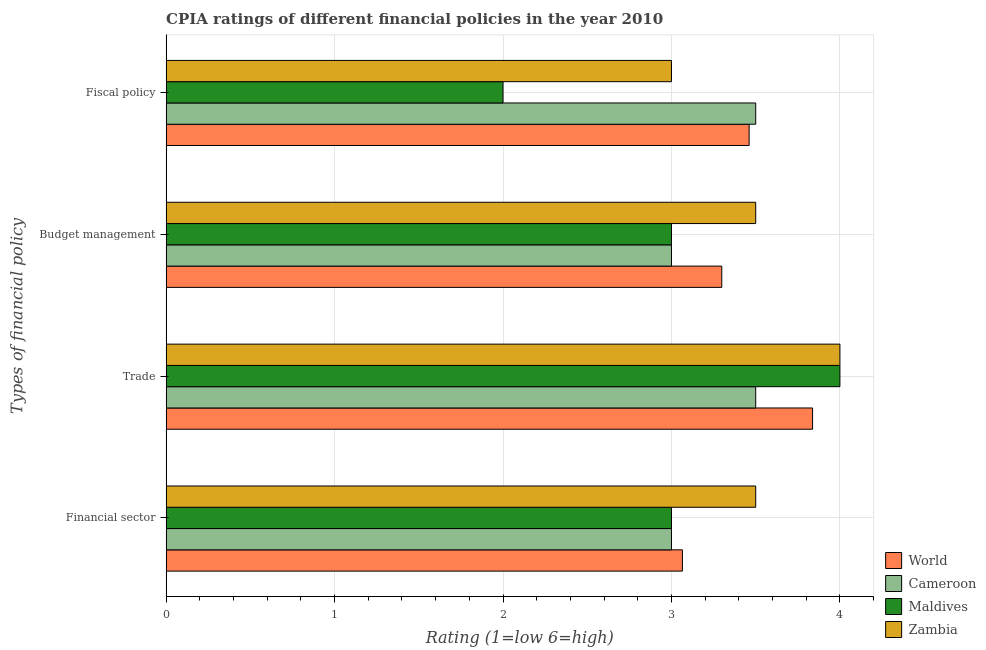How many different coloured bars are there?
Make the answer very short. 4. How many groups of bars are there?
Offer a terse response. 4. What is the label of the 1st group of bars from the top?
Provide a succinct answer. Fiscal policy. Across all countries, what is the maximum cpia rating of fiscal policy?
Provide a short and direct response. 3.5. Across all countries, what is the minimum cpia rating of financial sector?
Ensure brevity in your answer.  3. In which country was the cpia rating of budget management maximum?
Give a very brief answer. Zambia. In which country was the cpia rating of trade minimum?
Offer a very short reply. Cameroon. What is the total cpia rating of budget management in the graph?
Ensure brevity in your answer.  12.8. What is the average cpia rating of trade per country?
Provide a short and direct response. 3.83. What is the difference between the cpia rating of fiscal policy and cpia rating of trade in World?
Your answer should be compact. -0.38. In how many countries, is the cpia rating of budget management greater than 2.4 ?
Ensure brevity in your answer.  4. What is the ratio of the cpia rating of fiscal policy in Maldives to that in World?
Ensure brevity in your answer.  0.58. Is the cpia rating of budget management in Cameroon less than that in World?
Give a very brief answer. Yes. Is the difference between the cpia rating of trade in Cameroon and Zambia greater than the difference between the cpia rating of fiscal policy in Cameroon and Zambia?
Provide a succinct answer. No. What is the difference between the highest and the second highest cpia rating of trade?
Offer a terse response. 0. What is the difference between the highest and the lowest cpia rating of trade?
Provide a succinct answer. 0.5. Is the sum of the cpia rating of trade in Cameroon and World greater than the maximum cpia rating of financial sector across all countries?
Your answer should be very brief. Yes. Is it the case that in every country, the sum of the cpia rating of budget management and cpia rating of financial sector is greater than the sum of cpia rating of trade and cpia rating of fiscal policy?
Provide a succinct answer. No. What does the 1st bar from the top in Trade represents?
Your answer should be very brief. Zambia. What does the 4th bar from the bottom in Budget management represents?
Provide a short and direct response. Zambia. How many countries are there in the graph?
Give a very brief answer. 4. How many legend labels are there?
Offer a very short reply. 4. How are the legend labels stacked?
Your answer should be compact. Vertical. What is the title of the graph?
Give a very brief answer. CPIA ratings of different financial policies in the year 2010. What is the label or title of the Y-axis?
Make the answer very short. Types of financial policy. What is the Rating (1=low 6=high) in World in Financial sector?
Your response must be concise. 3.06. What is the Rating (1=low 6=high) in Cameroon in Financial sector?
Ensure brevity in your answer.  3. What is the Rating (1=low 6=high) in Maldives in Financial sector?
Your response must be concise. 3. What is the Rating (1=low 6=high) of Zambia in Financial sector?
Your answer should be compact. 3.5. What is the Rating (1=low 6=high) of World in Trade?
Make the answer very short. 3.84. What is the Rating (1=low 6=high) of Cameroon in Trade?
Offer a terse response. 3.5. What is the Rating (1=low 6=high) in Zambia in Trade?
Your answer should be very brief. 4. What is the Rating (1=low 6=high) in World in Budget management?
Your answer should be compact. 3.3. What is the Rating (1=low 6=high) in Maldives in Budget management?
Offer a very short reply. 3. What is the Rating (1=low 6=high) in Zambia in Budget management?
Offer a very short reply. 3.5. What is the Rating (1=low 6=high) of World in Fiscal policy?
Ensure brevity in your answer.  3.46. What is the Rating (1=low 6=high) of Zambia in Fiscal policy?
Give a very brief answer. 3. Across all Types of financial policy, what is the maximum Rating (1=low 6=high) of World?
Your response must be concise. 3.84. Across all Types of financial policy, what is the maximum Rating (1=low 6=high) in Cameroon?
Keep it short and to the point. 3.5. Across all Types of financial policy, what is the minimum Rating (1=low 6=high) in World?
Offer a terse response. 3.06. Across all Types of financial policy, what is the minimum Rating (1=low 6=high) of Zambia?
Your answer should be very brief. 3. What is the total Rating (1=low 6=high) in World in the graph?
Make the answer very short. 13.66. What is the total Rating (1=low 6=high) of Maldives in the graph?
Give a very brief answer. 12. What is the difference between the Rating (1=low 6=high) of World in Financial sector and that in Trade?
Your answer should be compact. -0.77. What is the difference between the Rating (1=low 6=high) in Cameroon in Financial sector and that in Trade?
Make the answer very short. -0.5. What is the difference between the Rating (1=low 6=high) of World in Financial sector and that in Budget management?
Provide a short and direct response. -0.23. What is the difference between the Rating (1=low 6=high) in Cameroon in Financial sector and that in Budget management?
Provide a short and direct response. 0. What is the difference between the Rating (1=low 6=high) of World in Financial sector and that in Fiscal policy?
Provide a short and direct response. -0.4. What is the difference between the Rating (1=low 6=high) in Zambia in Financial sector and that in Fiscal policy?
Give a very brief answer. 0.5. What is the difference between the Rating (1=low 6=high) of World in Trade and that in Budget management?
Your answer should be compact. 0.54. What is the difference between the Rating (1=low 6=high) of Cameroon in Trade and that in Budget management?
Your answer should be compact. 0.5. What is the difference between the Rating (1=low 6=high) in Zambia in Trade and that in Budget management?
Your response must be concise. 0.5. What is the difference between the Rating (1=low 6=high) in World in Trade and that in Fiscal policy?
Your answer should be very brief. 0.38. What is the difference between the Rating (1=low 6=high) of Cameroon in Trade and that in Fiscal policy?
Offer a terse response. 0. What is the difference between the Rating (1=low 6=high) in Maldives in Trade and that in Fiscal policy?
Provide a succinct answer. 2. What is the difference between the Rating (1=low 6=high) of World in Budget management and that in Fiscal policy?
Provide a short and direct response. -0.16. What is the difference between the Rating (1=low 6=high) of Cameroon in Budget management and that in Fiscal policy?
Offer a very short reply. -0.5. What is the difference between the Rating (1=low 6=high) of Maldives in Budget management and that in Fiscal policy?
Provide a succinct answer. 1. What is the difference between the Rating (1=low 6=high) of Zambia in Budget management and that in Fiscal policy?
Give a very brief answer. 0.5. What is the difference between the Rating (1=low 6=high) of World in Financial sector and the Rating (1=low 6=high) of Cameroon in Trade?
Provide a short and direct response. -0.44. What is the difference between the Rating (1=low 6=high) of World in Financial sector and the Rating (1=low 6=high) of Maldives in Trade?
Your answer should be very brief. -0.94. What is the difference between the Rating (1=low 6=high) of World in Financial sector and the Rating (1=low 6=high) of Zambia in Trade?
Offer a very short reply. -0.94. What is the difference between the Rating (1=low 6=high) of Cameroon in Financial sector and the Rating (1=low 6=high) of Zambia in Trade?
Keep it short and to the point. -1. What is the difference between the Rating (1=low 6=high) in Maldives in Financial sector and the Rating (1=low 6=high) in Zambia in Trade?
Give a very brief answer. -1. What is the difference between the Rating (1=low 6=high) in World in Financial sector and the Rating (1=low 6=high) in Cameroon in Budget management?
Your response must be concise. 0.06. What is the difference between the Rating (1=low 6=high) of World in Financial sector and the Rating (1=low 6=high) of Maldives in Budget management?
Offer a very short reply. 0.06. What is the difference between the Rating (1=low 6=high) of World in Financial sector and the Rating (1=low 6=high) of Zambia in Budget management?
Provide a succinct answer. -0.44. What is the difference between the Rating (1=low 6=high) of Cameroon in Financial sector and the Rating (1=low 6=high) of Maldives in Budget management?
Provide a short and direct response. 0. What is the difference between the Rating (1=low 6=high) of Cameroon in Financial sector and the Rating (1=low 6=high) of Zambia in Budget management?
Your answer should be very brief. -0.5. What is the difference between the Rating (1=low 6=high) of World in Financial sector and the Rating (1=low 6=high) of Cameroon in Fiscal policy?
Give a very brief answer. -0.44. What is the difference between the Rating (1=low 6=high) in World in Financial sector and the Rating (1=low 6=high) in Maldives in Fiscal policy?
Ensure brevity in your answer.  1.06. What is the difference between the Rating (1=low 6=high) in World in Financial sector and the Rating (1=low 6=high) in Zambia in Fiscal policy?
Give a very brief answer. 0.06. What is the difference between the Rating (1=low 6=high) in Cameroon in Financial sector and the Rating (1=low 6=high) in Maldives in Fiscal policy?
Your answer should be compact. 1. What is the difference between the Rating (1=low 6=high) of Cameroon in Financial sector and the Rating (1=low 6=high) of Zambia in Fiscal policy?
Keep it short and to the point. 0. What is the difference between the Rating (1=low 6=high) of World in Trade and the Rating (1=low 6=high) of Cameroon in Budget management?
Give a very brief answer. 0.84. What is the difference between the Rating (1=low 6=high) in World in Trade and the Rating (1=low 6=high) in Maldives in Budget management?
Your response must be concise. 0.84. What is the difference between the Rating (1=low 6=high) in World in Trade and the Rating (1=low 6=high) in Zambia in Budget management?
Offer a very short reply. 0.34. What is the difference between the Rating (1=low 6=high) in Cameroon in Trade and the Rating (1=low 6=high) in Maldives in Budget management?
Your response must be concise. 0.5. What is the difference between the Rating (1=low 6=high) in Maldives in Trade and the Rating (1=low 6=high) in Zambia in Budget management?
Give a very brief answer. 0.5. What is the difference between the Rating (1=low 6=high) of World in Trade and the Rating (1=low 6=high) of Cameroon in Fiscal policy?
Offer a very short reply. 0.34. What is the difference between the Rating (1=low 6=high) in World in Trade and the Rating (1=low 6=high) in Maldives in Fiscal policy?
Offer a very short reply. 1.84. What is the difference between the Rating (1=low 6=high) of World in Trade and the Rating (1=low 6=high) of Zambia in Fiscal policy?
Provide a succinct answer. 0.84. What is the difference between the Rating (1=low 6=high) in Cameroon in Trade and the Rating (1=low 6=high) in Maldives in Fiscal policy?
Ensure brevity in your answer.  1.5. What is the difference between the Rating (1=low 6=high) in Cameroon in Trade and the Rating (1=low 6=high) in Zambia in Fiscal policy?
Keep it short and to the point. 0.5. What is the difference between the Rating (1=low 6=high) of World in Budget management and the Rating (1=low 6=high) of Cameroon in Fiscal policy?
Make the answer very short. -0.2. What is the difference between the Rating (1=low 6=high) of World in Budget management and the Rating (1=low 6=high) of Maldives in Fiscal policy?
Keep it short and to the point. 1.3. What is the difference between the Rating (1=low 6=high) of World in Budget management and the Rating (1=low 6=high) of Zambia in Fiscal policy?
Ensure brevity in your answer.  0.3. What is the difference between the Rating (1=low 6=high) of Cameroon in Budget management and the Rating (1=low 6=high) of Maldives in Fiscal policy?
Offer a terse response. 1. What is the difference between the Rating (1=low 6=high) of Cameroon in Budget management and the Rating (1=low 6=high) of Zambia in Fiscal policy?
Ensure brevity in your answer.  0. What is the difference between the Rating (1=low 6=high) of Maldives in Budget management and the Rating (1=low 6=high) of Zambia in Fiscal policy?
Your answer should be compact. 0. What is the average Rating (1=low 6=high) of World per Types of financial policy?
Offer a terse response. 3.42. What is the average Rating (1=low 6=high) in Maldives per Types of financial policy?
Offer a very short reply. 3. What is the difference between the Rating (1=low 6=high) of World and Rating (1=low 6=high) of Cameroon in Financial sector?
Your answer should be compact. 0.06. What is the difference between the Rating (1=low 6=high) in World and Rating (1=low 6=high) in Maldives in Financial sector?
Offer a terse response. 0.06. What is the difference between the Rating (1=low 6=high) of World and Rating (1=low 6=high) of Zambia in Financial sector?
Provide a succinct answer. -0.44. What is the difference between the Rating (1=low 6=high) of Cameroon and Rating (1=low 6=high) of Maldives in Financial sector?
Your answer should be very brief. 0. What is the difference between the Rating (1=low 6=high) in Cameroon and Rating (1=low 6=high) in Zambia in Financial sector?
Your answer should be very brief. -0.5. What is the difference between the Rating (1=low 6=high) in World and Rating (1=low 6=high) in Cameroon in Trade?
Offer a terse response. 0.34. What is the difference between the Rating (1=low 6=high) in World and Rating (1=low 6=high) in Maldives in Trade?
Make the answer very short. -0.16. What is the difference between the Rating (1=low 6=high) of World and Rating (1=low 6=high) of Zambia in Trade?
Your answer should be compact. -0.16. What is the difference between the Rating (1=low 6=high) in Maldives and Rating (1=low 6=high) in Zambia in Trade?
Provide a short and direct response. 0. What is the difference between the Rating (1=low 6=high) of World and Rating (1=low 6=high) of Cameroon in Budget management?
Provide a succinct answer. 0.3. What is the difference between the Rating (1=low 6=high) in World and Rating (1=low 6=high) in Maldives in Budget management?
Make the answer very short. 0.3. What is the difference between the Rating (1=low 6=high) in World and Rating (1=low 6=high) in Zambia in Budget management?
Your answer should be very brief. -0.2. What is the difference between the Rating (1=low 6=high) of Cameroon and Rating (1=low 6=high) of Maldives in Budget management?
Make the answer very short. 0. What is the difference between the Rating (1=low 6=high) of World and Rating (1=low 6=high) of Cameroon in Fiscal policy?
Make the answer very short. -0.04. What is the difference between the Rating (1=low 6=high) of World and Rating (1=low 6=high) of Maldives in Fiscal policy?
Provide a succinct answer. 1.46. What is the difference between the Rating (1=low 6=high) in World and Rating (1=low 6=high) in Zambia in Fiscal policy?
Your answer should be compact. 0.46. What is the difference between the Rating (1=low 6=high) in Cameroon and Rating (1=low 6=high) in Maldives in Fiscal policy?
Your answer should be very brief. 1.5. What is the difference between the Rating (1=low 6=high) in Maldives and Rating (1=low 6=high) in Zambia in Fiscal policy?
Offer a very short reply. -1. What is the ratio of the Rating (1=low 6=high) in World in Financial sector to that in Trade?
Keep it short and to the point. 0.8. What is the ratio of the Rating (1=low 6=high) of Cameroon in Financial sector to that in Trade?
Provide a succinct answer. 0.86. What is the ratio of the Rating (1=low 6=high) of Zambia in Financial sector to that in Trade?
Ensure brevity in your answer.  0.88. What is the ratio of the Rating (1=low 6=high) in World in Financial sector to that in Budget management?
Keep it short and to the point. 0.93. What is the ratio of the Rating (1=low 6=high) of Cameroon in Financial sector to that in Budget management?
Make the answer very short. 1. What is the ratio of the Rating (1=low 6=high) of Zambia in Financial sector to that in Budget management?
Give a very brief answer. 1. What is the ratio of the Rating (1=low 6=high) in World in Financial sector to that in Fiscal policy?
Make the answer very short. 0.89. What is the ratio of the Rating (1=low 6=high) in Maldives in Financial sector to that in Fiscal policy?
Provide a succinct answer. 1.5. What is the ratio of the Rating (1=low 6=high) in World in Trade to that in Budget management?
Your answer should be compact. 1.16. What is the ratio of the Rating (1=low 6=high) in Zambia in Trade to that in Budget management?
Your answer should be very brief. 1.14. What is the ratio of the Rating (1=low 6=high) of World in Trade to that in Fiscal policy?
Provide a succinct answer. 1.11. What is the ratio of the Rating (1=low 6=high) of Cameroon in Trade to that in Fiscal policy?
Offer a very short reply. 1. What is the ratio of the Rating (1=low 6=high) in World in Budget management to that in Fiscal policy?
Provide a short and direct response. 0.95. What is the difference between the highest and the second highest Rating (1=low 6=high) in World?
Make the answer very short. 0.38. What is the difference between the highest and the second highest Rating (1=low 6=high) in Maldives?
Your answer should be compact. 1. What is the difference between the highest and the second highest Rating (1=low 6=high) of Zambia?
Your answer should be compact. 0.5. What is the difference between the highest and the lowest Rating (1=low 6=high) in World?
Make the answer very short. 0.77. What is the difference between the highest and the lowest Rating (1=low 6=high) of Cameroon?
Your answer should be compact. 0.5. 